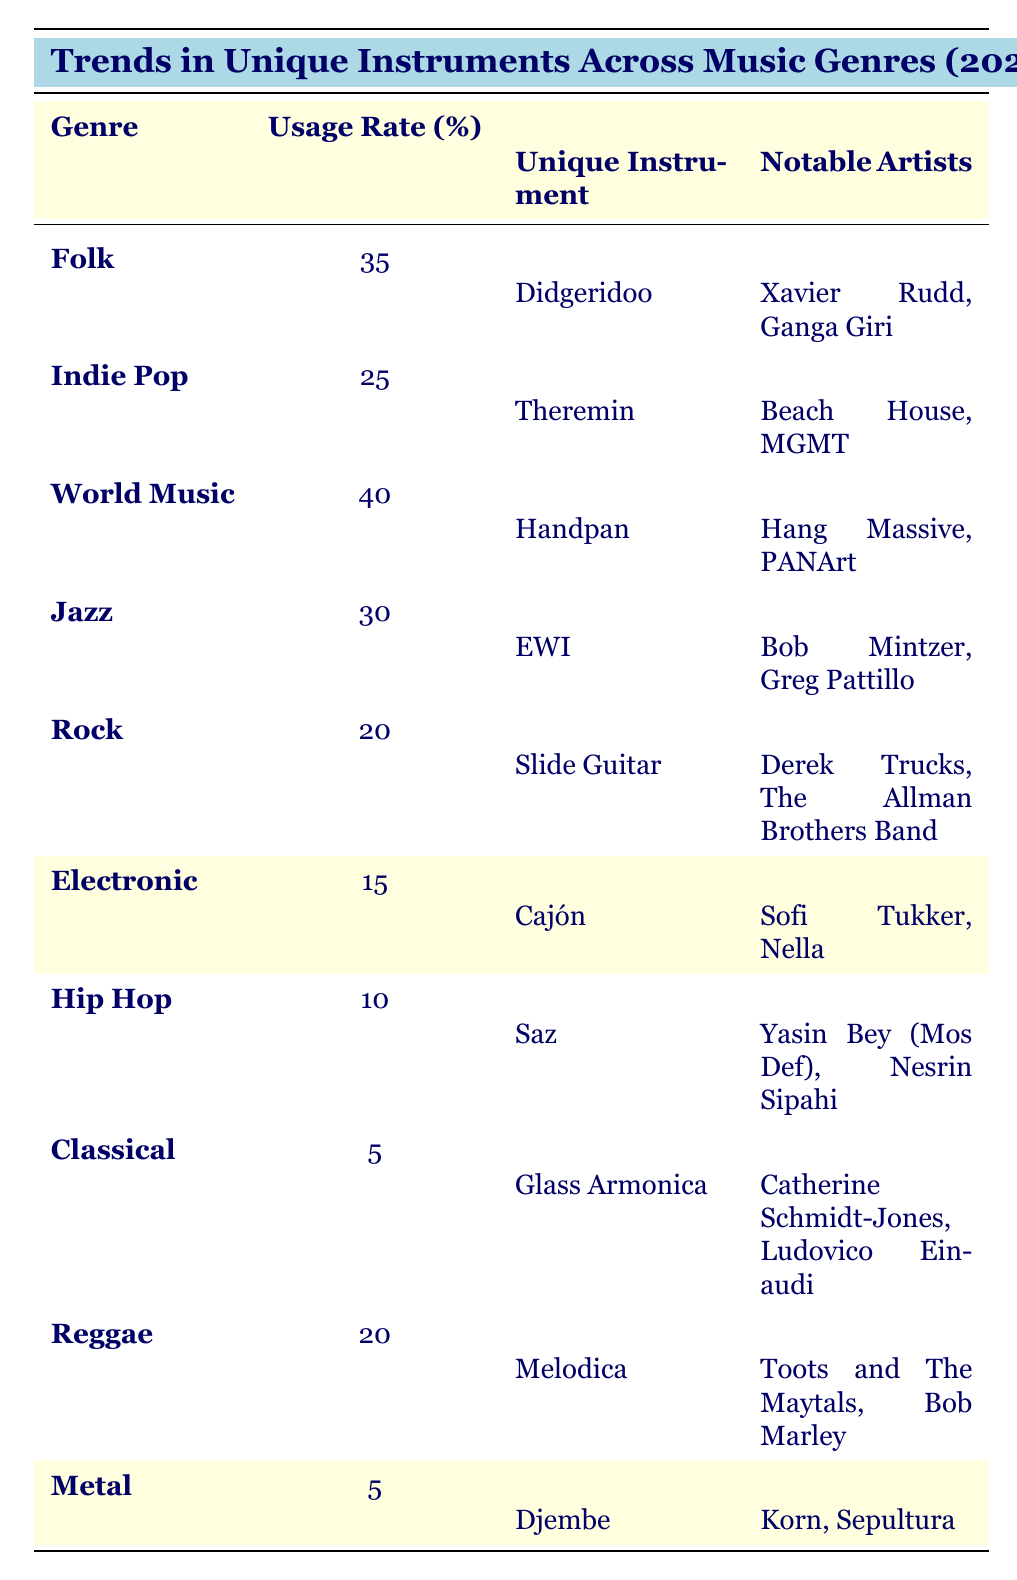What is the unique instrument used in the World Music genre? The table shows that the unique instrument for the World Music genre is the Handpan.
Answer: Handpan Which genre has the highest usage rate for unique instruments? By comparing the usage rates across all genres, World Music has the highest usage rate at 40%.
Answer: World Music How many genres have a usage rate of 20% or higher? The genres with a usage rate of 20% or higher are Folk (35%), World Music (40%), Jazz (30%), Indie Pop (25%), and Reggae (20%). There are five genres in total.
Answer: 5 Is the Theremin used more in Indie Pop or the Slide Guitar in Rock? The usage rate for Theremin in Indie Pop is 25%, while the Slide Guitar in Rock has a usage rate of 20%. Since 25% is greater than 20%, the Theremin is used more.
Answer: Yes Which instrument has the lowest usage rate, and in which genre is it used? The Glass Armonica has the lowest usage rate at 5%, and it is used in the Classical genre.
Answer: Glass Armonica, Classical If you combine the usage rates of Jazz, Indie Pop, and Electronic, what is the total? The usage rates are Jazz (30%), Indie Pop (25%), and Electronic (15%). Adding these gives 30 + 25 + 15 = 70%.
Answer: 70% Are the notable artists for the Cajón instrument primarily associated with Electronic music? The artists named for Cajón are Sofi Tukker and Nella, who are indeed associated with Electronic music.
Answer: Yes What notable artists are associated with the Didgeridoo in Folk music? According to the table, the notable artists associated with the Didgeridoo in Folk music are Xavier Rudd and Ganga Giri.
Answer: Xavier Rudd, Ganga Giri Is it true that Metal genre artists predominantly use the Djembe as a unique instrument? The table lists the Djembe as the unique instrument for Metal, but it also shows that its usage rate is only 5%, indicating it is not predominantly used.
Answer: No Which genre uses the Saz, and what is its usage rate? The Saz is used in the Hip Hop genre, and its usage rate is 10%.
Answer: Hip Hop, 10% 